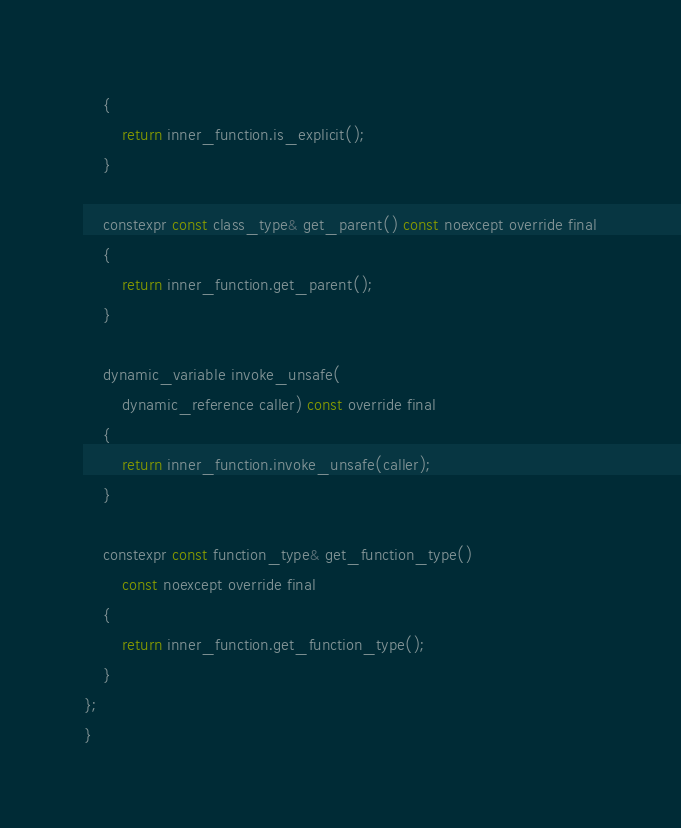Convert code to text. <code><loc_0><loc_0><loc_500><loc_500><_C_>	{
		return inner_function.is_explicit();
	}

	constexpr const class_type& get_parent() const noexcept override final
	{
		return inner_function.get_parent();
	}

	dynamic_variable invoke_unsafe(
		dynamic_reference caller) const override final
	{
		return inner_function.invoke_unsafe(caller);
	}

	constexpr const function_type& get_function_type()
		const noexcept override final
	{
		return inner_function.get_function_type();
	}
};
}
</code> 